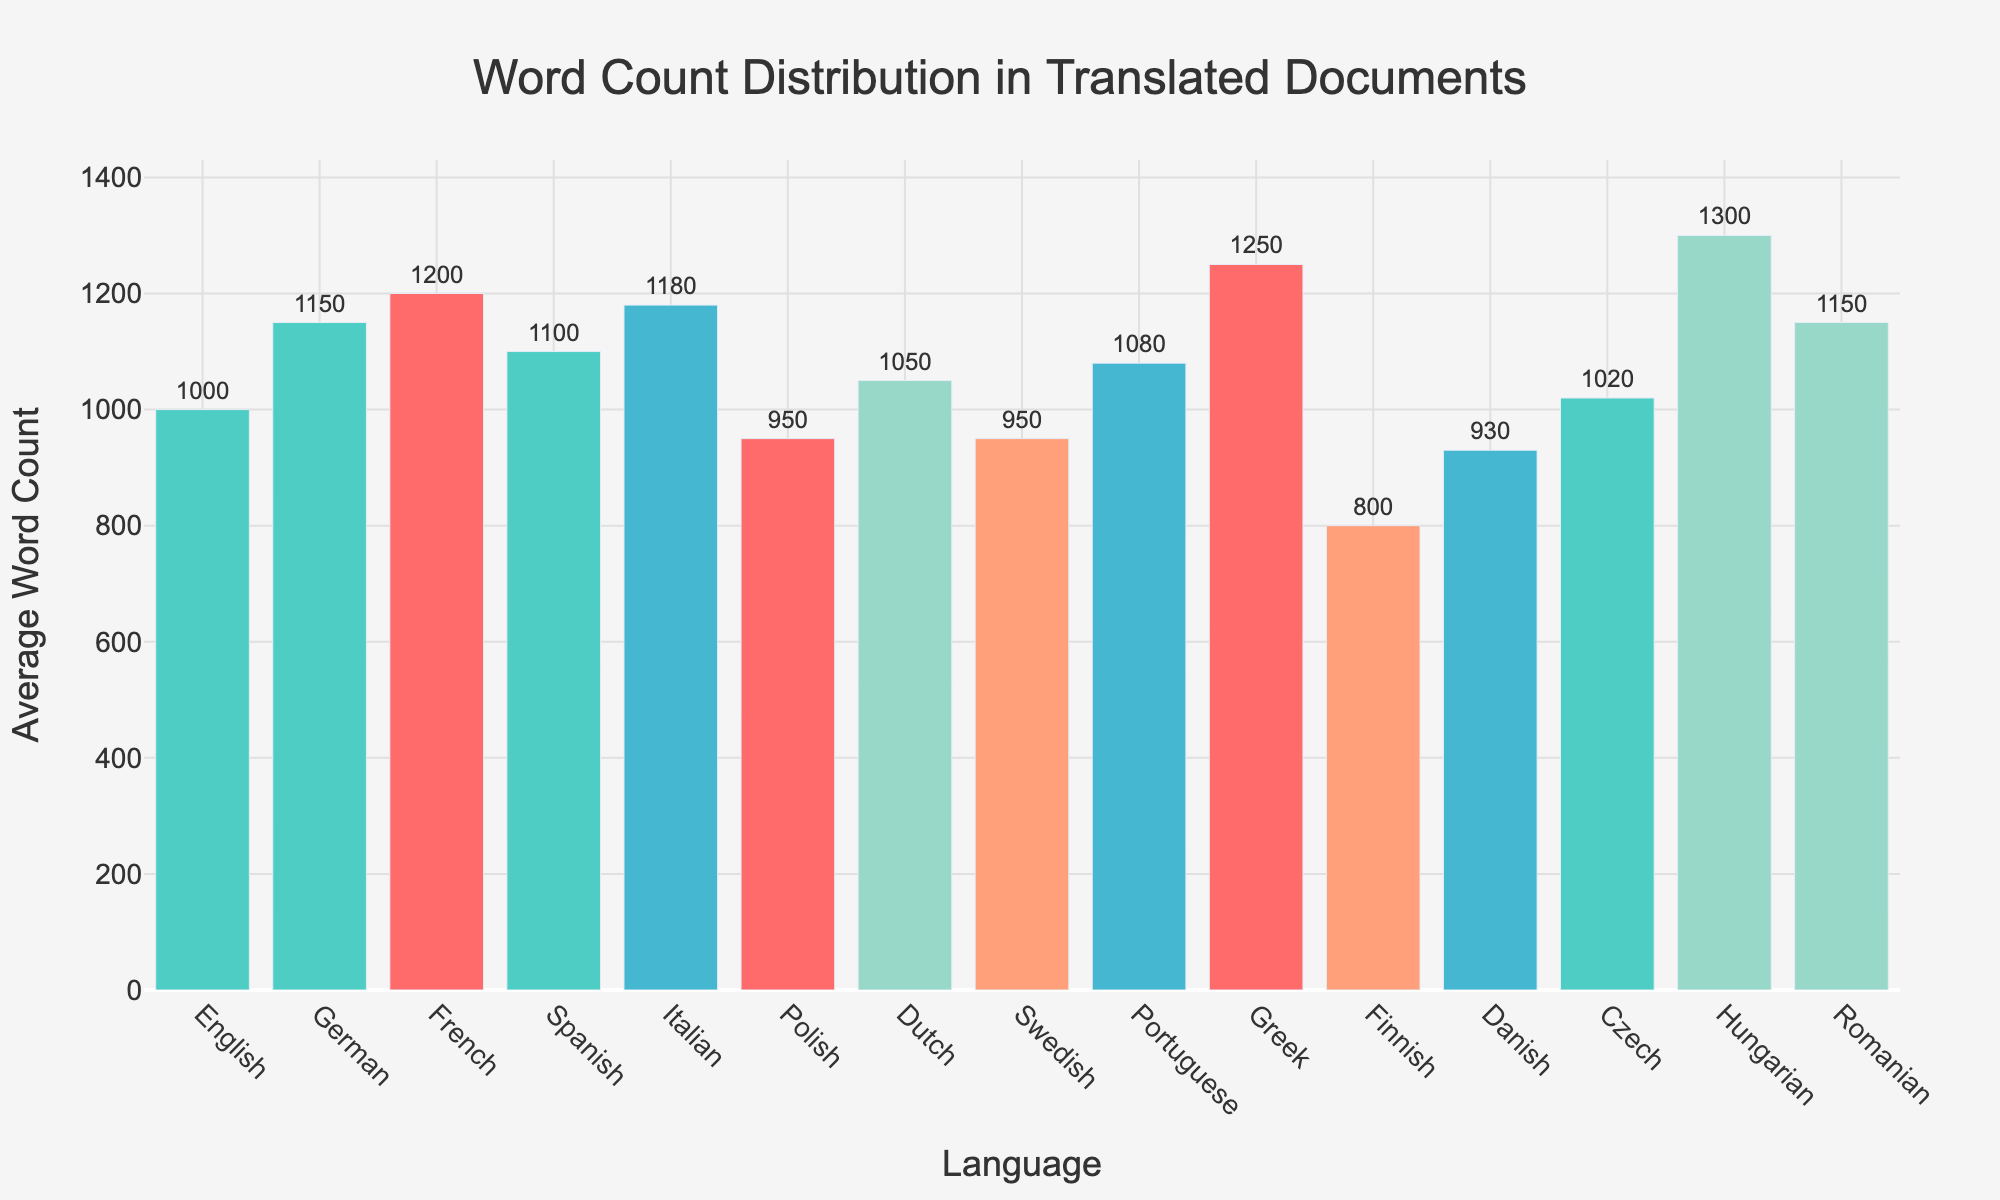What's the title of the figure? The title is clearly mentioned at the top of the figure, typically centered.
Answer: Word Count Distribution in Translated Documents How many languages are represented in the histogram? By counting the bars or checking the x-axis labels, we can determine the number of languages.
Answer: 15 Which language has the highest average word count? The highest bar in the histogram corresponds to the language with the highest average word count.
Answer: Hungarian Which two languages have the lowest average word counts? By identifying the two shortest bars in the histogram, we can determine the languages with the lowest average word counts.
Answer: Finnish and Danish What is the average word count for German? By looking at the bar corresponding to German, we can read the average word count value.
Answer: 1150 What is the difference in average word count between Hungarian and Finnish? Subtract the average word count of Finnish from that of Hungarian to find the difference.
Answer: 1300 - 800 = 500 Which language has a higher average word count: Spanish or Italian? Compare the heights of the bars for Spanish and Italian to see which one is higher.
Answer: Italian How many languages have an average word count greater than 1100? Count the number of bars that exceed the height of 1100 on the y-axis.
Answer: 6 What is the average word count for the languages with the top three highest values? Identify the top three highest bars (Hungarian, Greek, and French), sum their average word counts, and divide by three for the average.
Answer: (1300 + 1250 + 1200) / 3 = 1250 Is the average word count for Polish higher than Swedish? Compare the bars for Polish and Swedish to determine which is higher.
Answer: Yes 